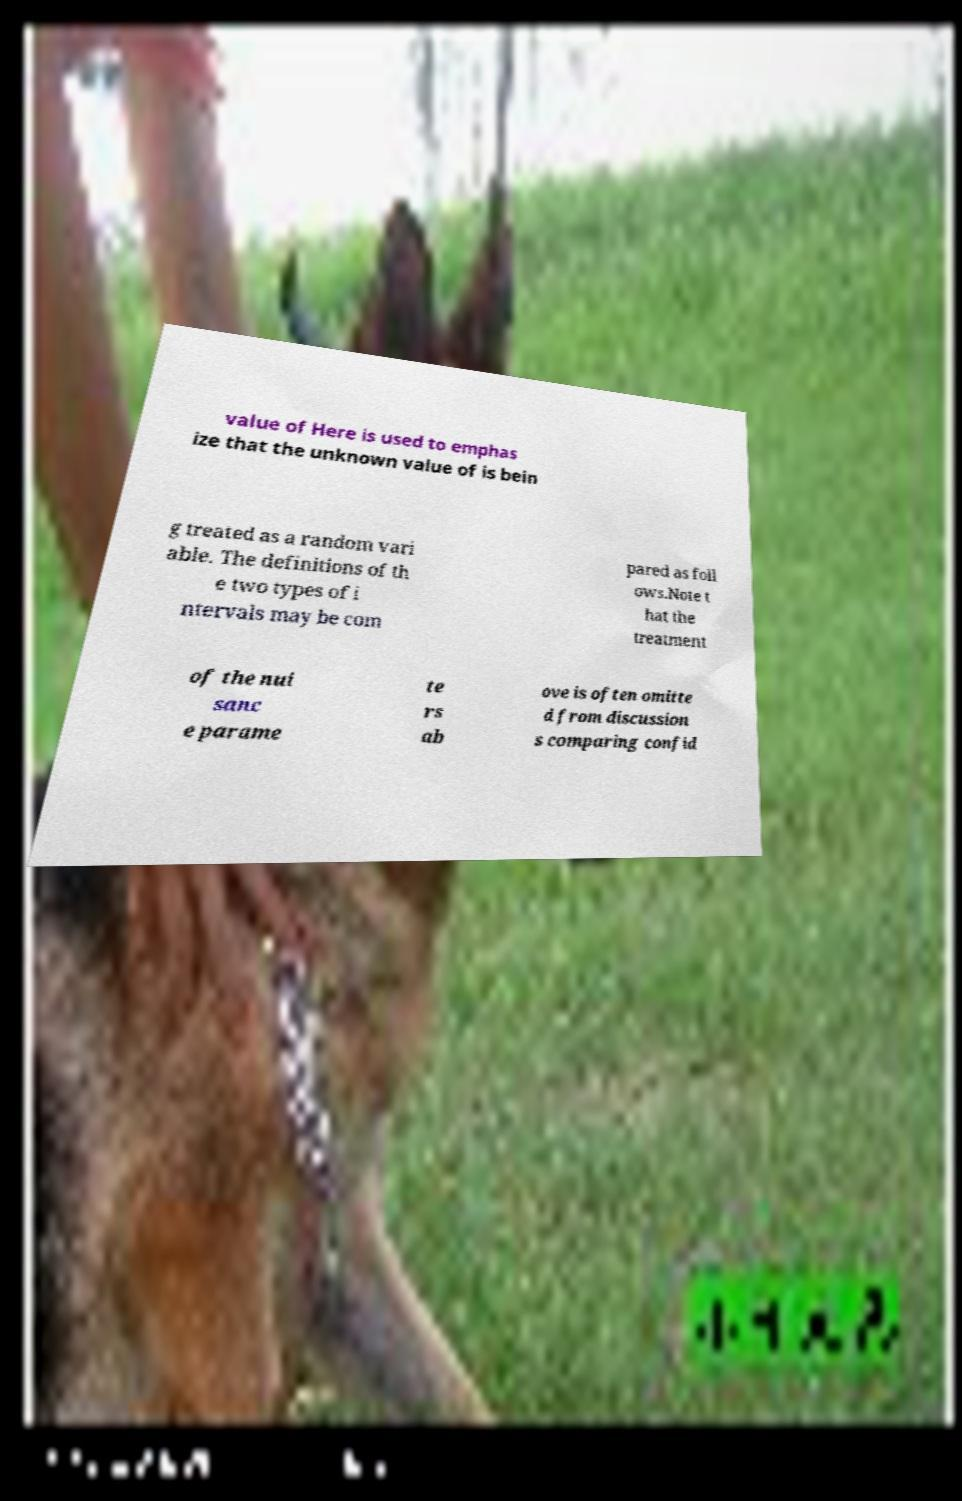What messages or text are displayed in this image? I need them in a readable, typed format. value of Here is used to emphas ize that the unknown value of is bein g treated as a random vari able. The definitions of th e two types of i ntervals may be com pared as foll ows.Note t hat the treatment of the nui sanc e parame te rs ab ove is often omitte d from discussion s comparing confid 